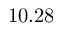<formula> <loc_0><loc_0><loc_500><loc_500>1 0 . 2 8</formula> 